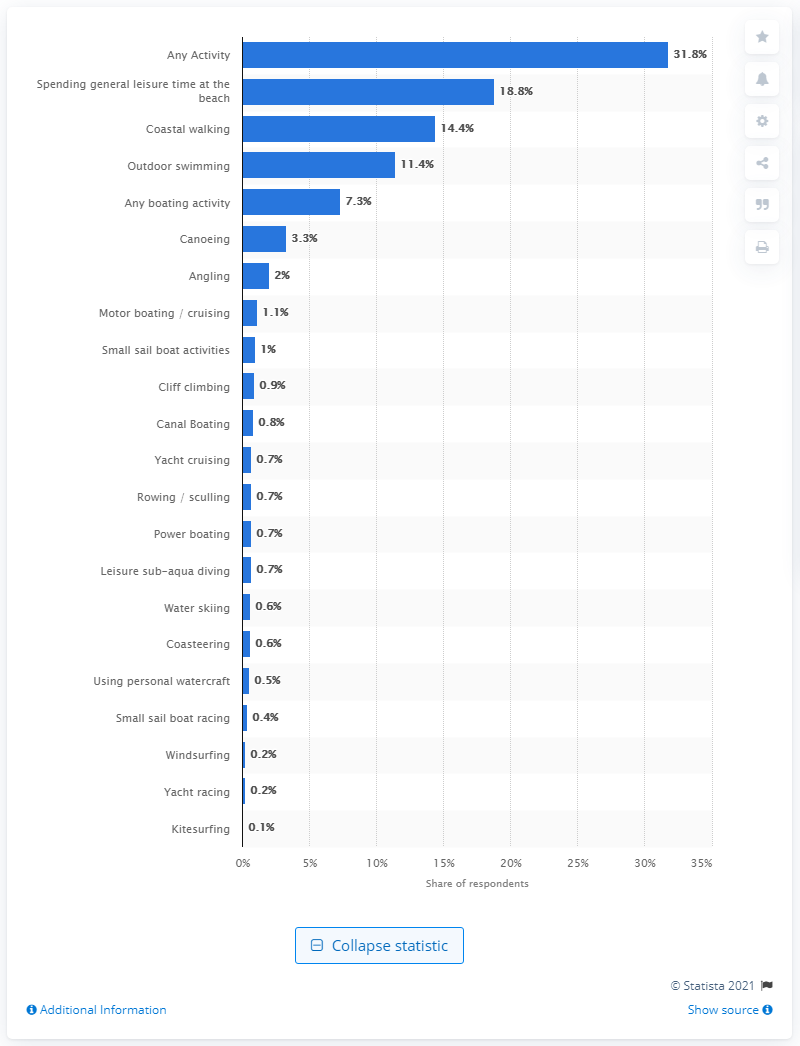Indicate a few pertinent items in this graphic. In 2018, 0.8% of respondents reported participating in canal boating. 